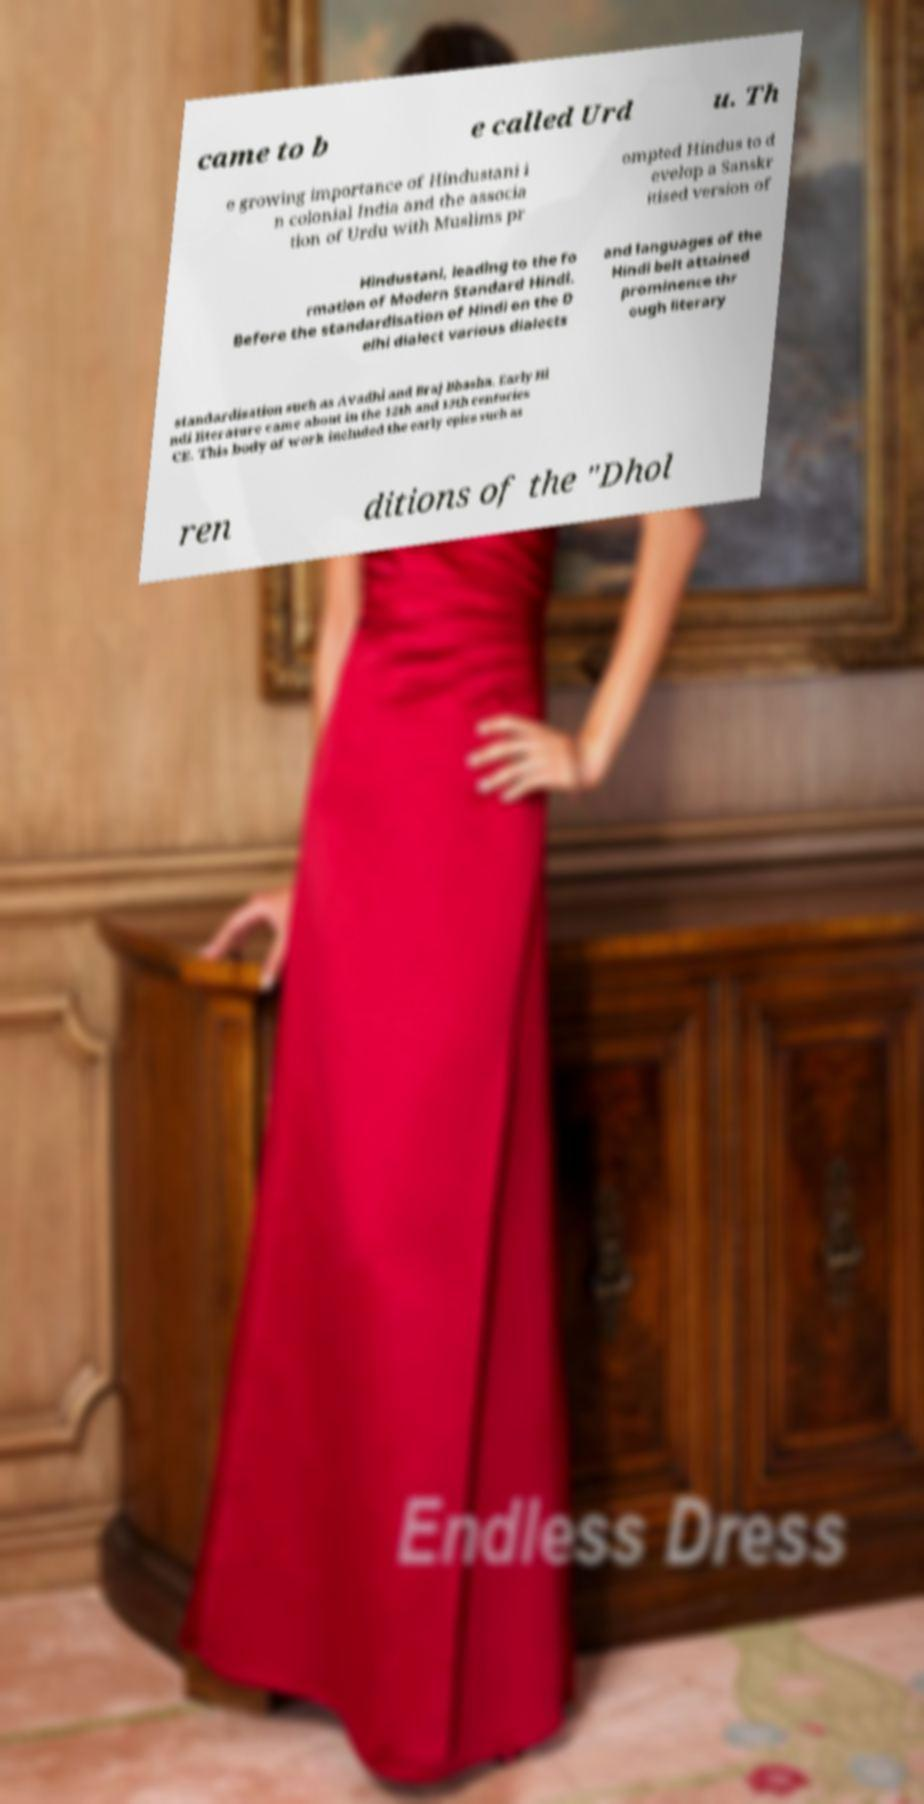Could you assist in decoding the text presented in this image and type it out clearly? came to b e called Urd u. Th e growing importance of Hindustani i n colonial India and the associa tion of Urdu with Muslims pr ompted Hindus to d evelop a Sanskr itised version of Hindustani, leading to the fo rmation of Modern Standard Hindi. Before the standardisation of Hindi on the D elhi dialect various dialects and languages of the Hindi belt attained prominence thr ough literary standardisation such as Avadhi and Braj Bhasha. Early Hi ndi literature came about in the 12th and 13th centuries CE. This body of work included the early epics such as ren ditions of the "Dhol 